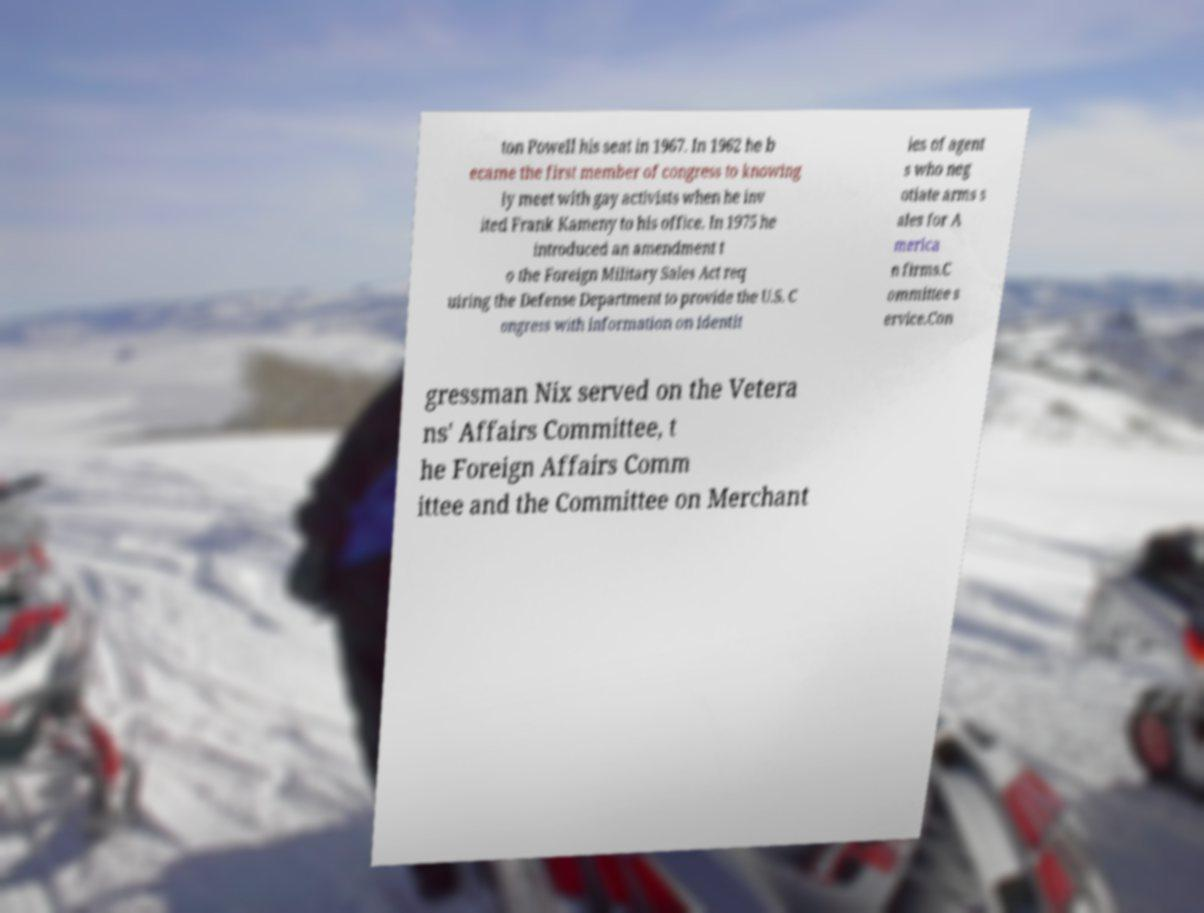Could you assist in decoding the text presented in this image and type it out clearly? ton Powell his seat in 1967. In 1962 he b ecame the first member of congress to knowing ly meet with gay activists when he inv ited Frank Kameny to his office. In 1975 he introduced an amendment t o the Foreign Military Sales Act req uiring the Defense Department to provide the U.S. C ongress with information on identit ies of agent s who neg otiate arms s ales for A merica n firms.C ommittee s ervice.Con gressman Nix served on the Vetera ns' Affairs Committee, t he Foreign Affairs Comm ittee and the Committee on Merchant 